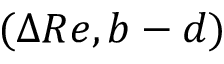Convert formula to latex. <formula><loc_0><loc_0><loc_500><loc_500>( \Delta R e , b - d )</formula> 